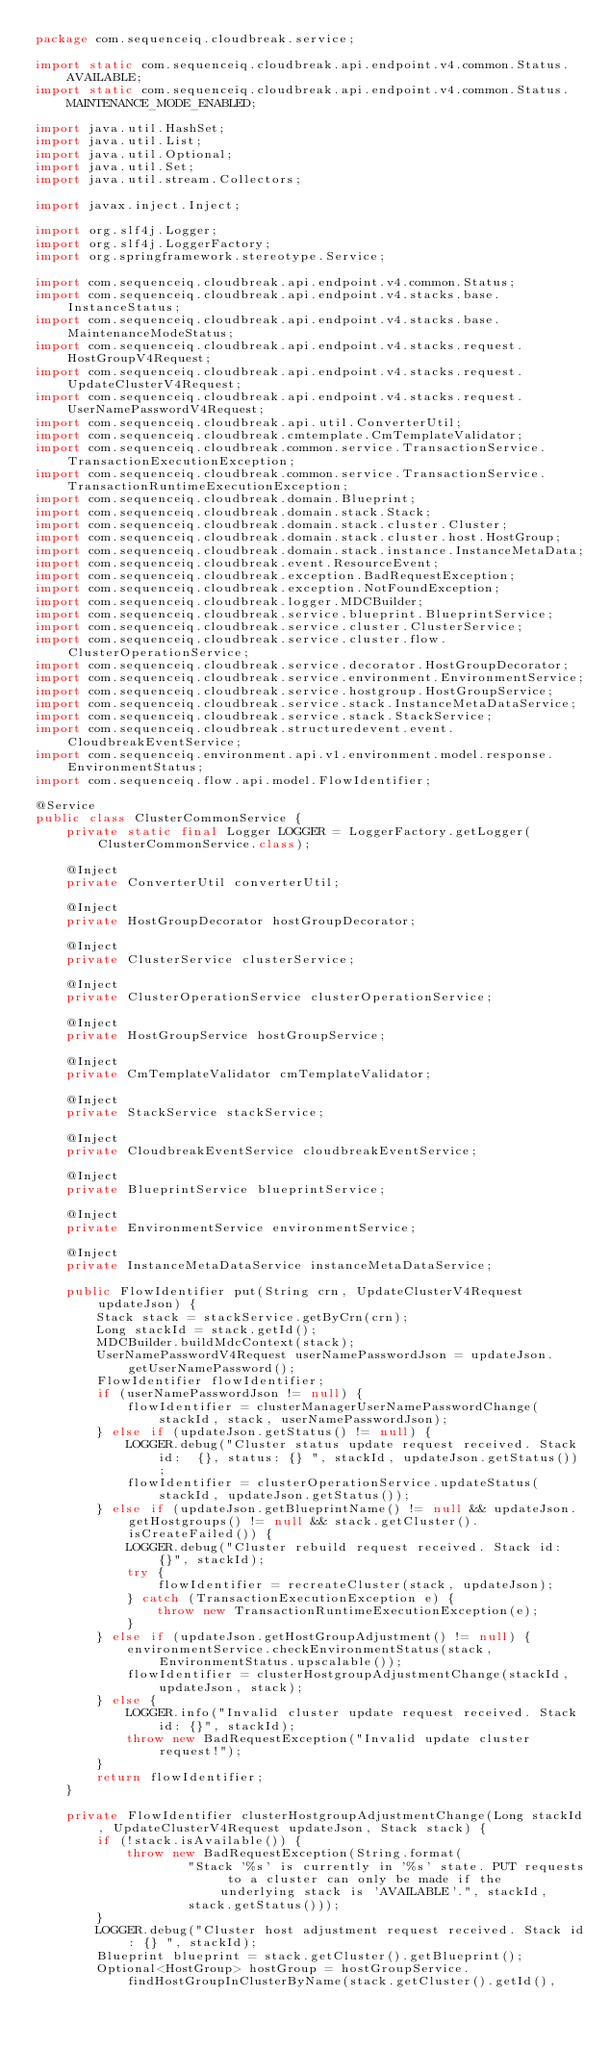<code> <loc_0><loc_0><loc_500><loc_500><_Java_>package com.sequenceiq.cloudbreak.service;

import static com.sequenceiq.cloudbreak.api.endpoint.v4.common.Status.AVAILABLE;
import static com.sequenceiq.cloudbreak.api.endpoint.v4.common.Status.MAINTENANCE_MODE_ENABLED;

import java.util.HashSet;
import java.util.List;
import java.util.Optional;
import java.util.Set;
import java.util.stream.Collectors;

import javax.inject.Inject;

import org.slf4j.Logger;
import org.slf4j.LoggerFactory;
import org.springframework.stereotype.Service;

import com.sequenceiq.cloudbreak.api.endpoint.v4.common.Status;
import com.sequenceiq.cloudbreak.api.endpoint.v4.stacks.base.InstanceStatus;
import com.sequenceiq.cloudbreak.api.endpoint.v4.stacks.base.MaintenanceModeStatus;
import com.sequenceiq.cloudbreak.api.endpoint.v4.stacks.request.HostGroupV4Request;
import com.sequenceiq.cloudbreak.api.endpoint.v4.stacks.request.UpdateClusterV4Request;
import com.sequenceiq.cloudbreak.api.endpoint.v4.stacks.request.UserNamePasswordV4Request;
import com.sequenceiq.cloudbreak.api.util.ConverterUtil;
import com.sequenceiq.cloudbreak.cmtemplate.CmTemplateValidator;
import com.sequenceiq.cloudbreak.common.service.TransactionService.TransactionExecutionException;
import com.sequenceiq.cloudbreak.common.service.TransactionService.TransactionRuntimeExecutionException;
import com.sequenceiq.cloudbreak.domain.Blueprint;
import com.sequenceiq.cloudbreak.domain.stack.Stack;
import com.sequenceiq.cloudbreak.domain.stack.cluster.Cluster;
import com.sequenceiq.cloudbreak.domain.stack.cluster.host.HostGroup;
import com.sequenceiq.cloudbreak.domain.stack.instance.InstanceMetaData;
import com.sequenceiq.cloudbreak.event.ResourceEvent;
import com.sequenceiq.cloudbreak.exception.BadRequestException;
import com.sequenceiq.cloudbreak.exception.NotFoundException;
import com.sequenceiq.cloudbreak.logger.MDCBuilder;
import com.sequenceiq.cloudbreak.service.blueprint.BlueprintService;
import com.sequenceiq.cloudbreak.service.cluster.ClusterService;
import com.sequenceiq.cloudbreak.service.cluster.flow.ClusterOperationService;
import com.sequenceiq.cloudbreak.service.decorator.HostGroupDecorator;
import com.sequenceiq.cloudbreak.service.environment.EnvironmentService;
import com.sequenceiq.cloudbreak.service.hostgroup.HostGroupService;
import com.sequenceiq.cloudbreak.service.stack.InstanceMetaDataService;
import com.sequenceiq.cloudbreak.service.stack.StackService;
import com.sequenceiq.cloudbreak.structuredevent.event.CloudbreakEventService;
import com.sequenceiq.environment.api.v1.environment.model.response.EnvironmentStatus;
import com.sequenceiq.flow.api.model.FlowIdentifier;

@Service
public class ClusterCommonService {
    private static final Logger LOGGER = LoggerFactory.getLogger(ClusterCommonService.class);

    @Inject
    private ConverterUtil converterUtil;

    @Inject
    private HostGroupDecorator hostGroupDecorator;

    @Inject
    private ClusterService clusterService;

    @Inject
    private ClusterOperationService clusterOperationService;

    @Inject
    private HostGroupService hostGroupService;

    @Inject
    private CmTemplateValidator cmTemplateValidator;

    @Inject
    private StackService stackService;

    @Inject
    private CloudbreakEventService cloudbreakEventService;

    @Inject
    private BlueprintService blueprintService;

    @Inject
    private EnvironmentService environmentService;

    @Inject
    private InstanceMetaDataService instanceMetaDataService;

    public FlowIdentifier put(String crn, UpdateClusterV4Request updateJson) {
        Stack stack = stackService.getByCrn(crn);
        Long stackId = stack.getId();
        MDCBuilder.buildMdcContext(stack);
        UserNamePasswordV4Request userNamePasswordJson = updateJson.getUserNamePassword();
        FlowIdentifier flowIdentifier;
        if (userNamePasswordJson != null) {
            flowIdentifier = clusterManagerUserNamePasswordChange(stackId, stack, userNamePasswordJson);
        } else if (updateJson.getStatus() != null) {
            LOGGER.debug("Cluster status update request received. Stack id:  {}, status: {} ", stackId, updateJson.getStatus());
            flowIdentifier = clusterOperationService.updateStatus(stackId, updateJson.getStatus());
        } else if (updateJson.getBlueprintName() != null && updateJson.getHostgroups() != null && stack.getCluster().isCreateFailed()) {
            LOGGER.debug("Cluster rebuild request received. Stack id:  {}", stackId);
            try {
                flowIdentifier = recreateCluster(stack, updateJson);
            } catch (TransactionExecutionException e) {
                throw new TransactionRuntimeExecutionException(e);
            }
        } else if (updateJson.getHostGroupAdjustment() != null) {
            environmentService.checkEnvironmentStatus(stack, EnvironmentStatus.upscalable());
            flowIdentifier = clusterHostgroupAdjustmentChange(stackId, updateJson, stack);
        } else {
            LOGGER.info("Invalid cluster update request received. Stack id: {}", stackId);
            throw new BadRequestException("Invalid update cluster request!");
        }
        return flowIdentifier;
    }

    private FlowIdentifier clusterHostgroupAdjustmentChange(Long stackId, UpdateClusterV4Request updateJson, Stack stack) {
        if (!stack.isAvailable()) {
            throw new BadRequestException(String.format(
                    "Stack '%s' is currently in '%s' state. PUT requests to a cluster can only be made if the underlying stack is 'AVAILABLE'.", stackId,
                    stack.getStatus()));
        }
        LOGGER.debug("Cluster host adjustment request received. Stack id: {} ", stackId);
        Blueprint blueprint = stack.getCluster().getBlueprint();
        Optional<HostGroup> hostGroup = hostGroupService.findHostGroupInClusterByName(stack.getCluster().getId(),</code> 